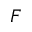<formula> <loc_0><loc_0><loc_500><loc_500>F</formula> 